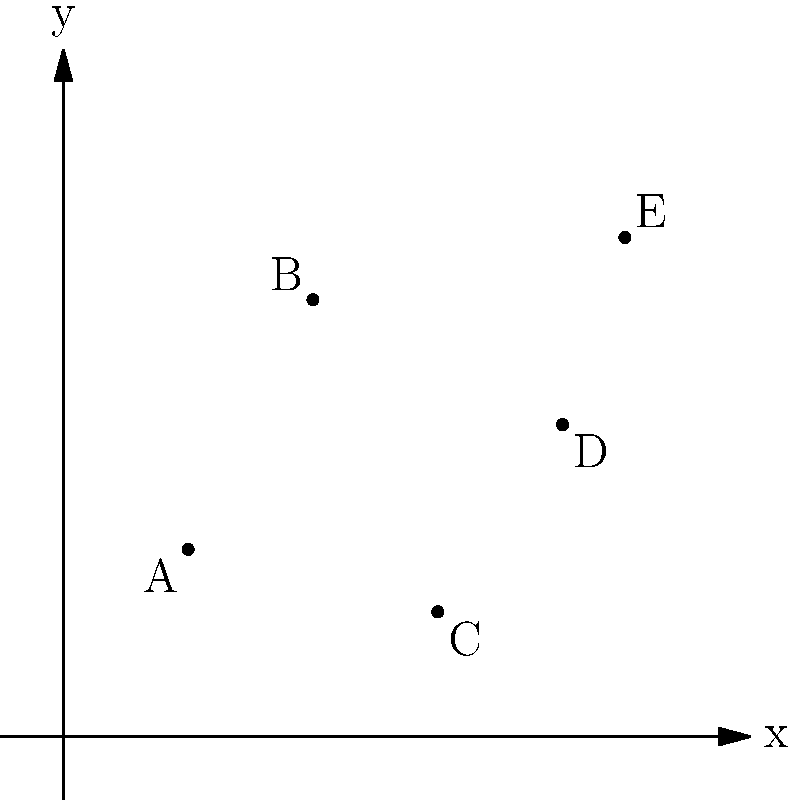Mo's Kebabs is planning to open a new shop in Exmouth. The coordinates of five regular customer locations (in km) are plotted on the graph: A(2,3), B(4,7), C(6,2), D(8,5), and E(9,8). To minimize the total distance traveled by customers, Mo wants to locate the new shop at the centroid of these points. Calculate the coordinates of the optimal location for the new kebab shop. To find the centroid (average position) of the given points, we need to follow these steps:

1. Sum up all x-coordinates:
   $x_{sum} = 2 + 4 + 6 + 8 + 9 = 29$

2. Sum up all y-coordinates:
   $y_{sum} = 3 + 7 + 2 + 5 + 8 = 25$

3. Count the total number of points:
   $n = 5$

4. Calculate the x-coordinate of the centroid:
   $x_{centroid} = \frac{x_{sum}}{n} = \frac{29}{5} = 5.8$

5. Calculate the y-coordinate of the centroid:
   $y_{centroid} = \frac{y_{sum}}{n} = \frac{25}{5} = 5$

Therefore, the optimal location for the new kebab shop is at the point (5.8, 5).
Answer: (5.8, 5) 